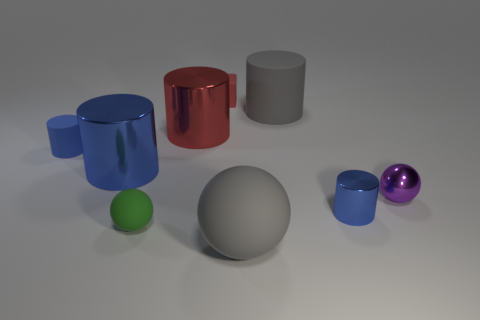How many blue cylinders must be subtracted to get 1 blue cylinders? 2 Subtract all blue balls. How many blue cylinders are left? 3 Subtract 1 cylinders. How many cylinders are left? 4 Add 1 yellow matte cubes. How many objects exist? 10 Subtract all cylinders. How many objects are left? 4 Subtract 0 blue balls. How many objects are left? 9 Subtract all small gray matte spheres. Subtract all large matte cylinders. How many objects are left? 8 Add 7 red shiny things. How many red shiny things are left? 8 Add 8 big blue matte objects. How many big blue matte objects exist? 8 